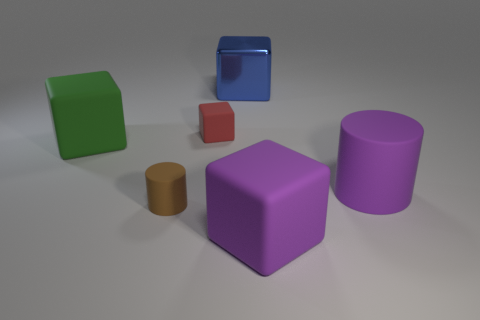Add 3 brown matte cubes. How many objects exist? 9 Subtract all cylinders. How many objects are left? 4 Subtract all large purple matte things. Subtract all small rubber objects. How many objects are left? 2 Add 3 brown matte cylinders. How many brown matte cylinders are left? 4 Add 4 big shiny blocks. How many big shiny blocks exist? 5 Subtract 1 purple blocks. How many objects are left? 5 